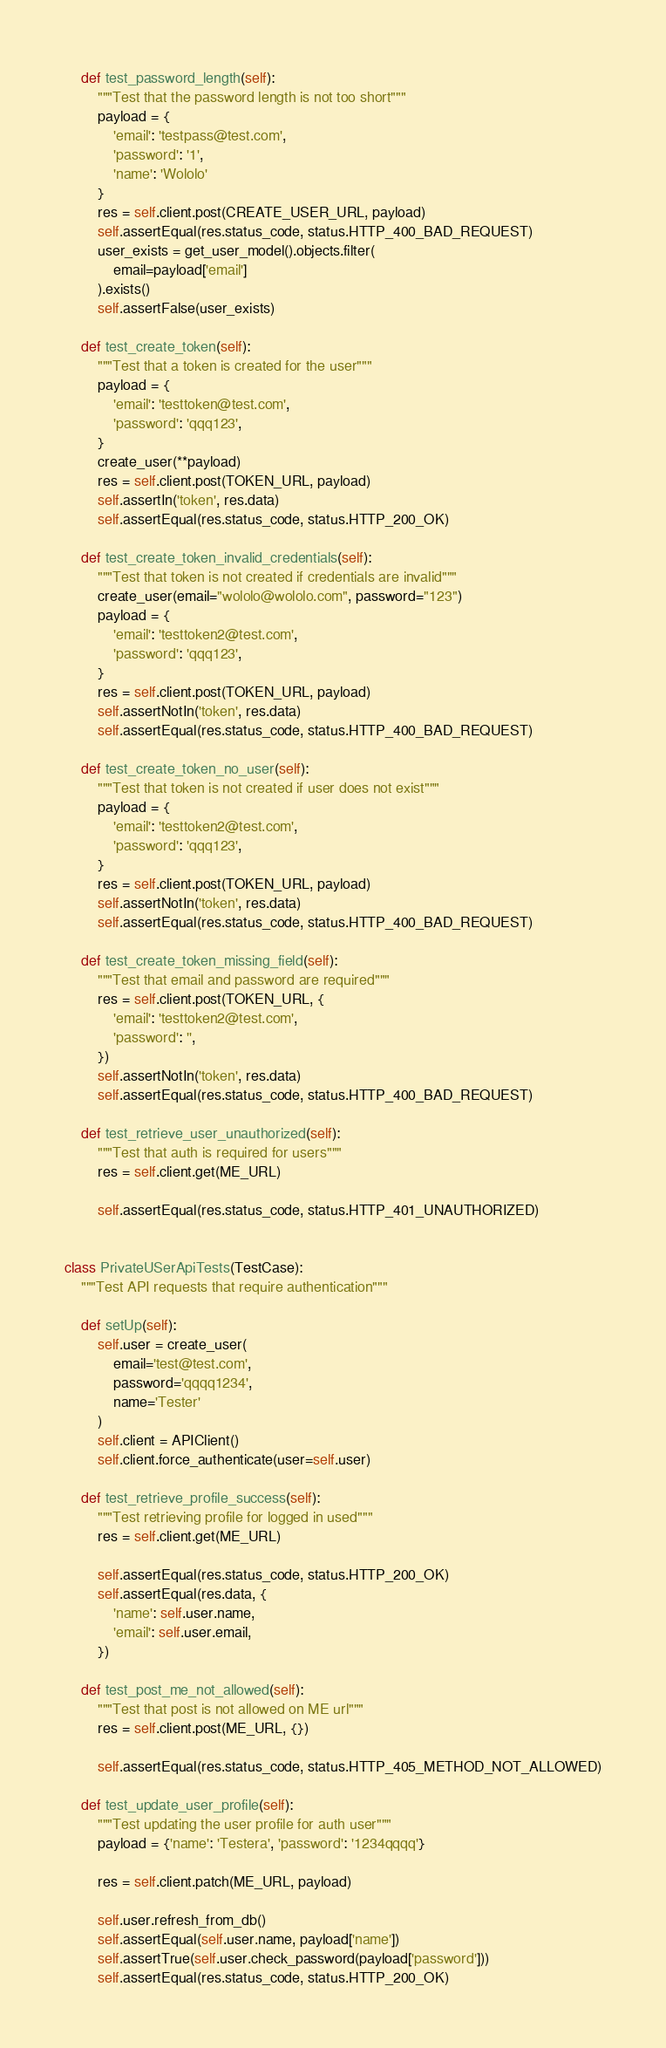Convert code to text. <code><loc_0><loc_0><loc_500><loc_500><_Python_>    def test_password_length(self):
        """Test that the password length is not too short"""
        payload = {
            'email': 'testpass@test.com',
            'password': '1',
            'name': 'Wololo'
        }
        res = self.client.post(CREATE_USER_URL, payload)
        self.assertEqual(res.status_code, status.HTTP_400_BAD_REQUEST)
        user_exists = get_user_model().objects.filter(
            email=payload['email']
        ).exists()
        self.assertFalse(user_exists)

    def test_create_token(self):
        """Test that a token is created for the user"""
        payload = {
            'email': 'testtoken@test.com',
            'password': 'qqq123',
        }
        create_user(**payload)
        res = self.client.post(TOKEN_URL, payload)
        self.assertIn('token', res.data)
        self.assertEqual(res.status_code, status.HTTP_200_OK)

    def test_create_token_invalid_credentials(self):
        """Test that token is not created if credentials are invalid"""
        create_user(email="wololo@wololo.com", password="123")
        payload = {
            'email': 'testtoken2@test.com',
            'password': 'qqq123',
        }
        res = self.client.post(TOKEN_URL, payload)
        self.assertNotIn('token', res.data)
        self.assertEqual(res.status_code, status.HTTP_400_BAD_REQUEST)

    def test_create_token_no_user(self):
        """Test that token is not created if user does not exist"""
        payload = {
            'email': 'testtoken2@test.com',
            'password': 'qqq123',
        }
        res = self.client.post(TOKEN_URL, payload)
        self.assertNotIn('token', res.data)
        self.assertEqual(res.status_code, status.HTTP_400_BAD_REQUEST)

    def test_create_token_missing_field(self):
        """Test that email and password are required"""
        res = self.client.post(TOKEN_URL, {
            'email': 'testtoken2@test.com',
            'password': '',
        })
        self.assertNotIn('token', res.data)
        self.assertEqual(res.status_code, status.HTTP_400_BAD_REQUEST)

    def test_retrieve_user_unauthorized(self):
        """Test that auth is required for users"""
        res = self.client.get(ME_URL)

        self.assertEqual(res.status_code, status.HTTP_401_UNAUTHORIZED)


class PrivateUSerApiTests(TestCase):
    """Test API requests that require authentication"""

    def setUp(self):
        self.user = create_user(
            email='test@test.com',
            password='qqqq1234',
            name='Tester'
        )
        self.client = APIClient()
        self.client.force_authenticate(user=self.user)

    def test_retrieve_profile_success(self):
        """Test retrieving profile for logged in used"""
        res = self.client.get(ME_URL)

        self.assertEqual(res.status_code, status.HTTP_200_OK)
        self.assertEqual(res.data, {
            'name': self.user.name,
            'email': self.user.email,
        })

    def test_post_me_not_allowed(self):
        """Test that post is not allowed on ME url"""
        res = self.client.post(ME_URL, {})

        self.assertEqual(res.status_code, status.HTTP_405_METHOD_NOT_ALLOWED)

    def test_update_user_profile(self):
        """Test updating the user profile for auth user"""
        payload = {'name': 'Testera', 'password': '1234qqqq'}

        res = self.client.patch(ME_URL, payload)

        self.user.refresh_from_db()
        self.assertEqual(self.user.name, payload['name'])
        self.assertTrue(self.user.check_password(payload['password']))
        self.assertEqual(res.status_code, status.HTTP_200_OK)
</code> 